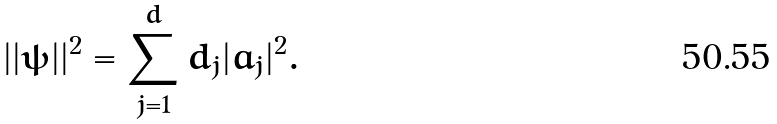<formula> <loc_0><loc_0><loc_500><loc_500>| | \psi | | ^ { 2 } = \sum _ { j = 1 } ^ { d } d _ { j } | a _ { j } | ^ { 2 } .</formula> 